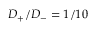<formula> <loc_0><loc_0><loc_500><loc_500>D _ { + } / D _ { - } = 1 / 1 0</formula> 